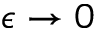Convert formula to latex. <formula><loc_0><loc_0><loc_500><loc_500>\epsilon \to 0</formula> 